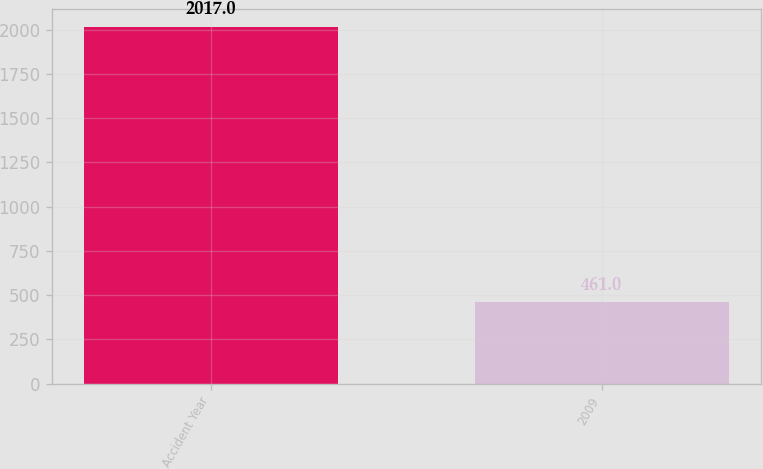Convert chart to OTSL. <chart><loc_0><loc_0><loc_500><loc_500><bar_chart><fcel>Accident Year<fcel>2009<nl><fcel>2017<fcel>461<nl></chart> 